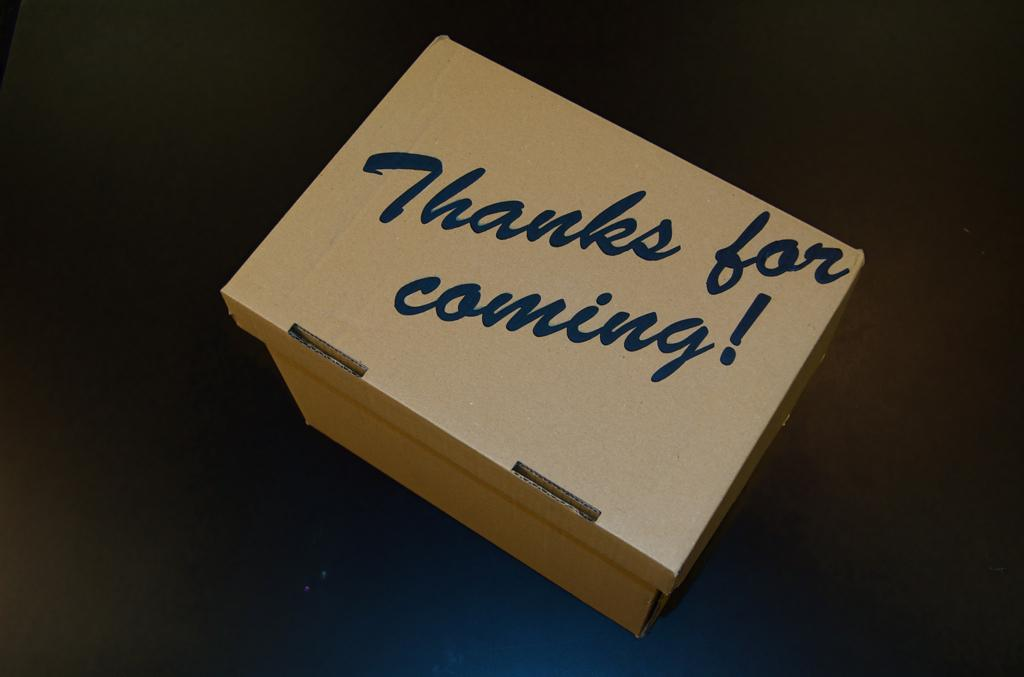<image>
Create a compact narrative representing the image presented. a box with the words Thanks For Coming on the lid 